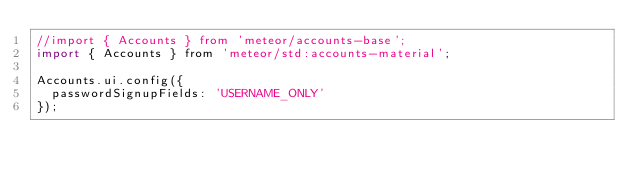<code> <loc_0><loc_0><loc_500><loc_500><_JavaScript_>//import { Accounts } from 'meteor/accounts-base';
import { Accounts } from 'meteor/std:accounts-material';

Accounts.ui.config({
  passwordSignupFields: 'USERNAME_ONLY'
});
</code> 